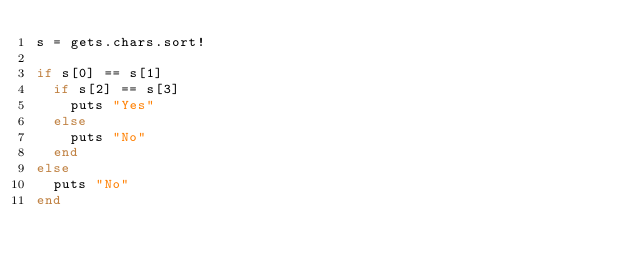<code> <loc_0><loc_0><loc_500><loc_500><_Ruby_>s = gets.chars.sort!

if s[0] == s[1] 
  if s[2] == s[3]
  	puts "Yes"
	else
  	puts "No"
  end
else
  puts "No"
end</code> 